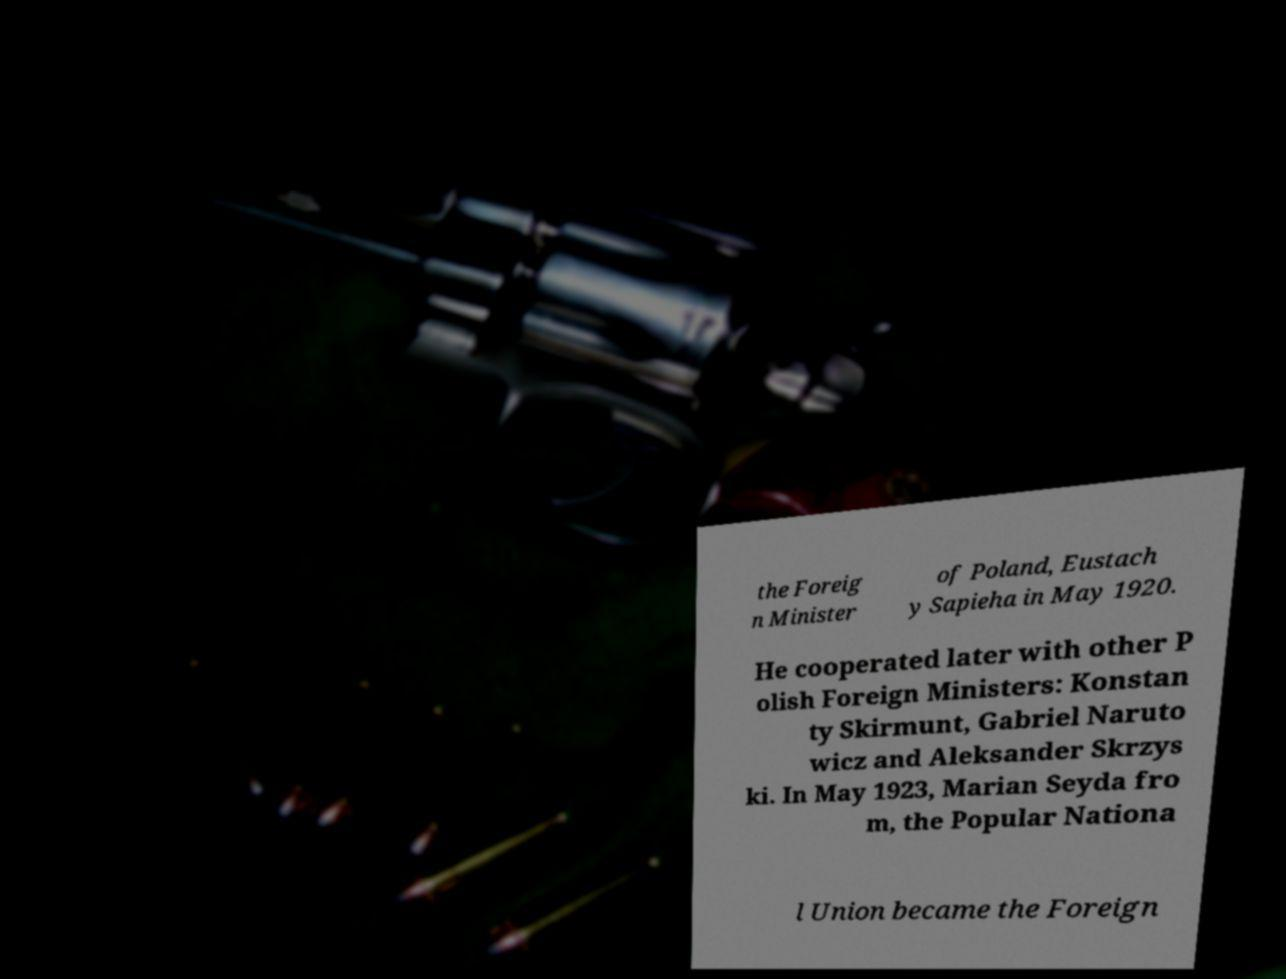There's text embedded in this image that I need extracted. Can you transcribe it verbatim? the Foreig n Minister of Poland, Eustach y Sapieha in May 1920. He cooperated later with other P olish Foreign Ministers: Konstan ty Skirmunt, Gabriel Naruto wicz and Aleksander Skrzys ki. In May 1923, Marian Seyda fro m, the Popular Nationa l Union became the Foreign 